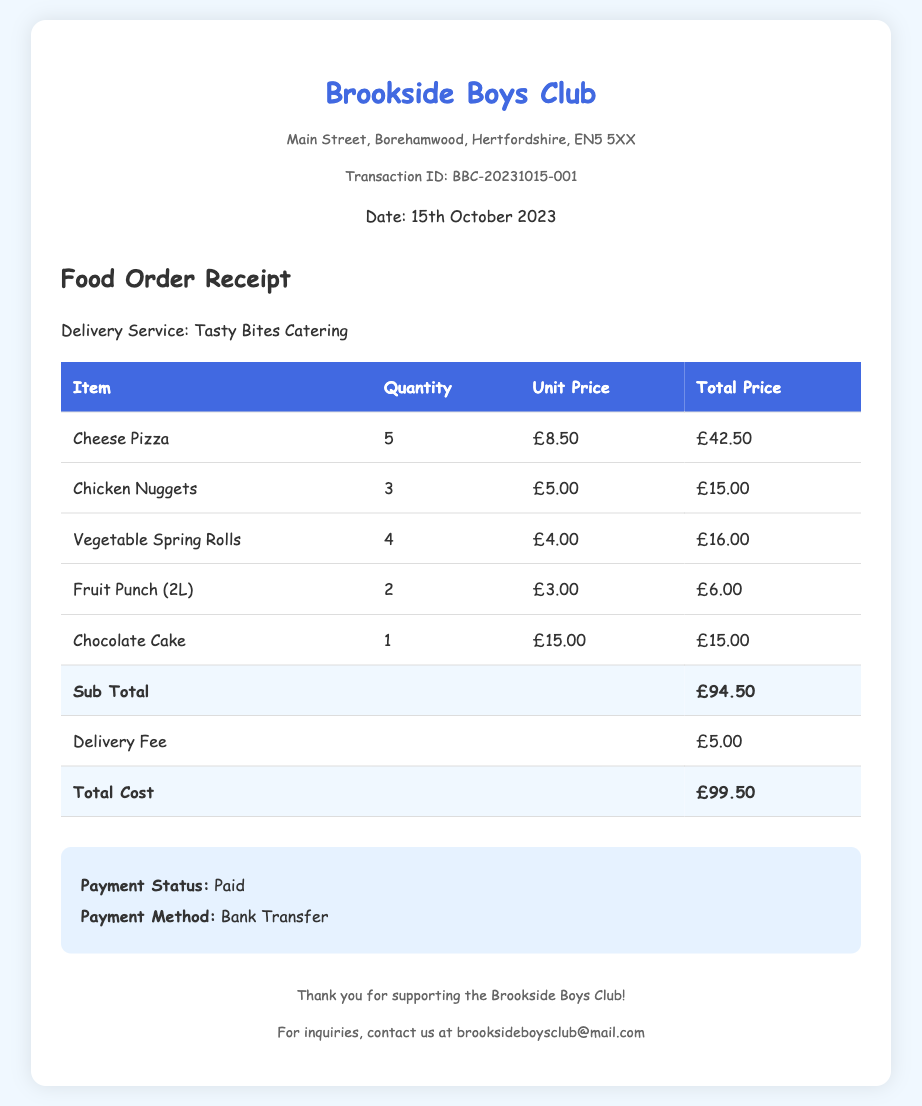What is the date of the transaction? The transaction date is specified in the document as "15th October 2023".
Answer: 15th October 2023 What is the Transaction ID? The document includes a unique identifier for the transaction, which is "BBC-20231015-001".
Answer: BBC-20231015-001 How many Chicken Nuggets were ordered? The receipt shows that 3 units of Chicken Nuggets were included in the order.
Answer: 3 What is the unit price of Cheese Pizza? The document lists the unit price for Cheese Pizza as £8.50.
Answer: £8.50 What is the total cost of the order? The total cost is provided at the bottom of the order details, summing all prices as £99.50.
Answer: £99.50 What was the delivery fee? The document specifies that the delivery fee was £5.00.
Answer: £5.00 How many Fruit Punch bottles were ordered? The order shows there were 2 units of Fruit Punch (2L) ordered.
Answer: 2 What is the payment status? The document indicates that the payment status of the order is "Paid".
Answer: Paid What is the name of the delivery service? The receipt mentions "Tasty Bites Catering" as the delivery service used for the order.
Answer: Tasty Bites Catering 